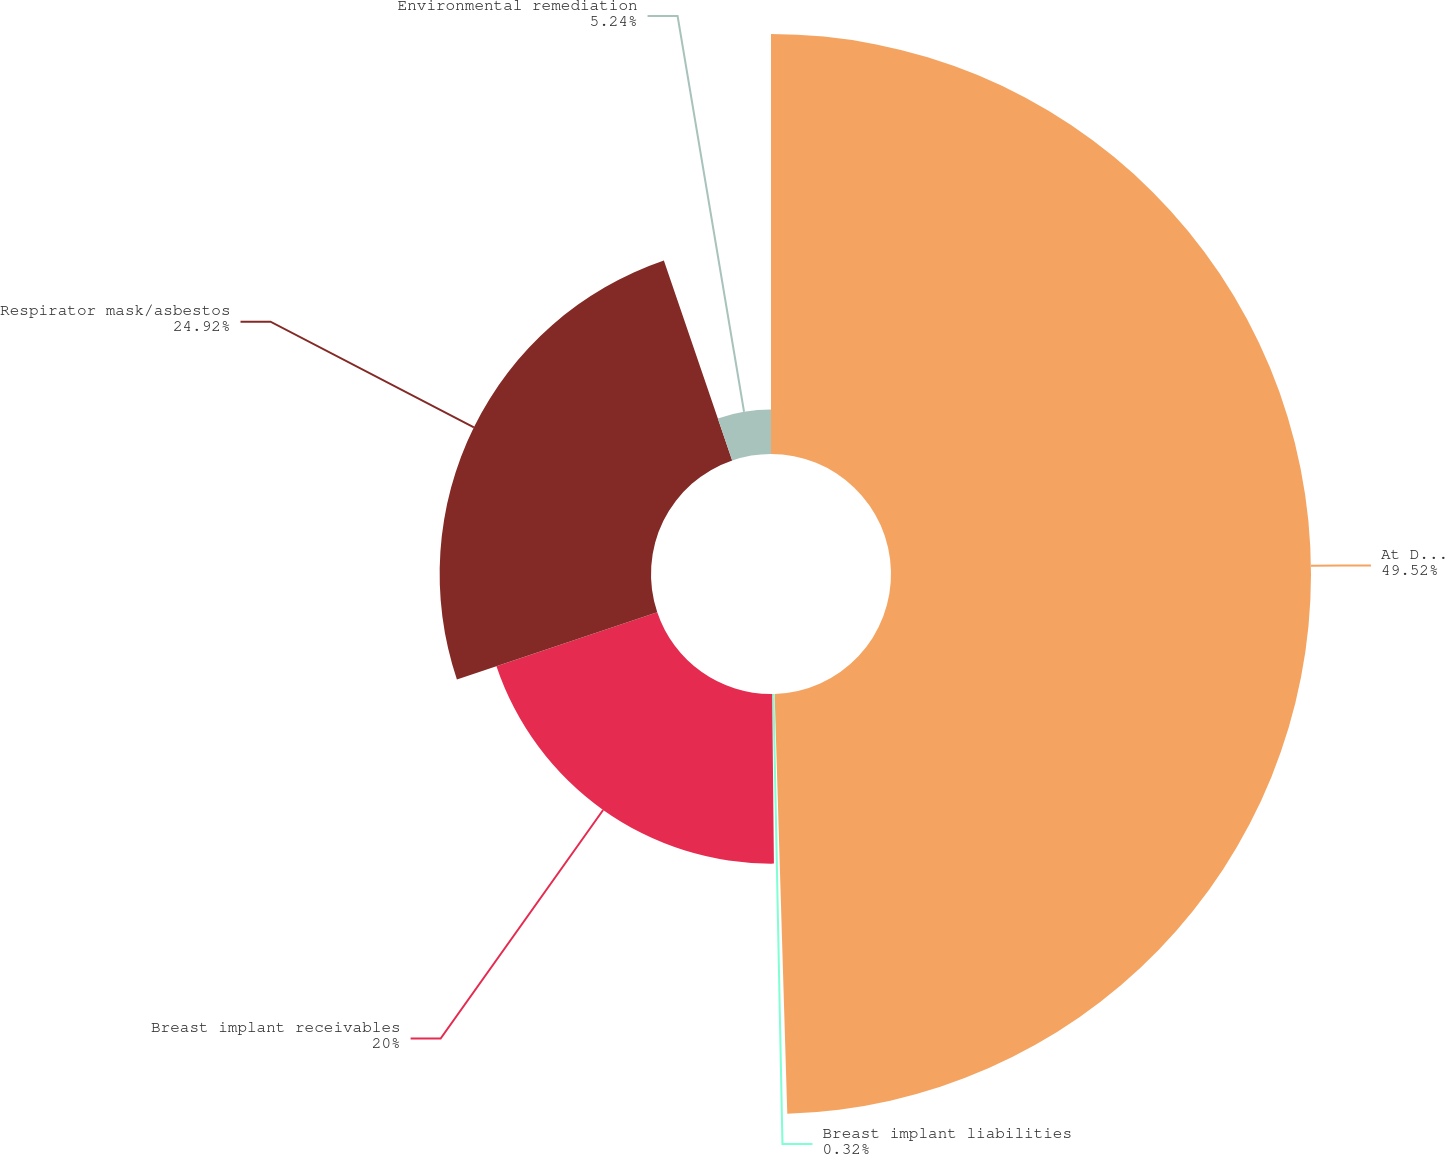Convert chart to OTSL. <chart><loc_0><loc_0><loc_500><loc_500><pie_chart><fcel>At December 31 (Millions)<fcel>Breast implant liabilities<fcel>Breast implant receivables<fcel>Respirator mask/asbestos<fcel>Environmental remediation<nl><fcel>49.52%<fcel>0.32%<fcel>20.0%<fcel>24.92%<fcel>5.24%<nl></chart> 